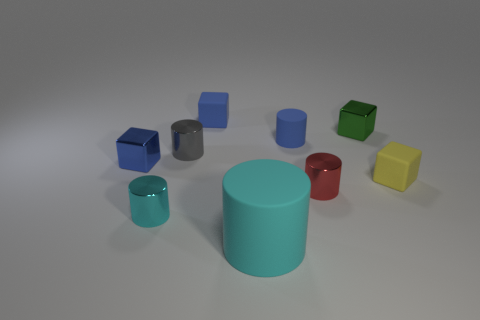Subtract 2 cylinders. How many cylinders are left? 3 Subtract all gray cylinders. How many cylinders are left? 4 Subtract all small red cylinders. How many cylinders are left? 4 Subtract all brown cylinders. Subtract all yellow blocks. How many cylinders are left? 5 Subtract all cylinders. How many objects are left? 4 Add 5 cyan spheres. How many cyan spheres exist? 5 Subtract 0 purple cylinders. How many objects are left? 9 Subtract all cylinders. Subtract all cyan cubes. How many objects are left? 4 Add 4 small metallic cubes. How many small metallic cubes are left? 6 